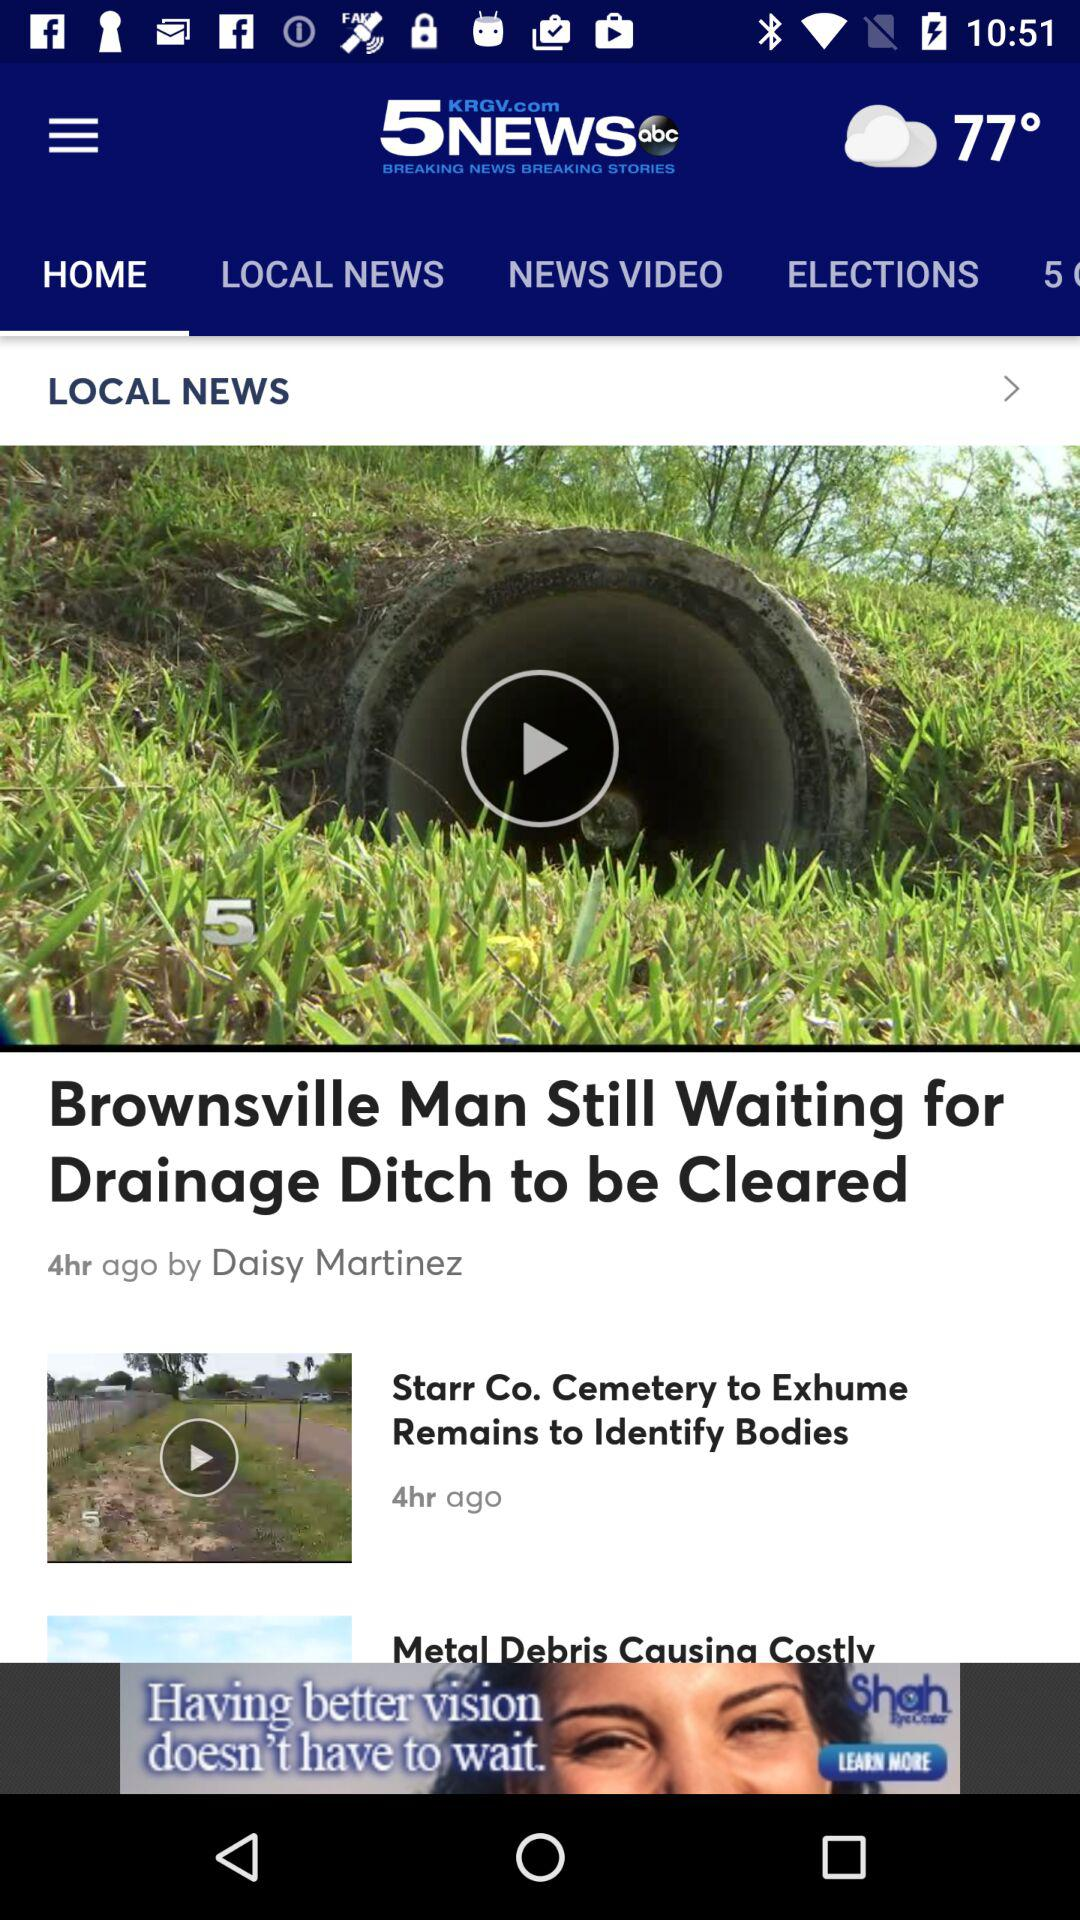How many news stories are featured on the screen?
Answer the question using a single word or phrase. 3 